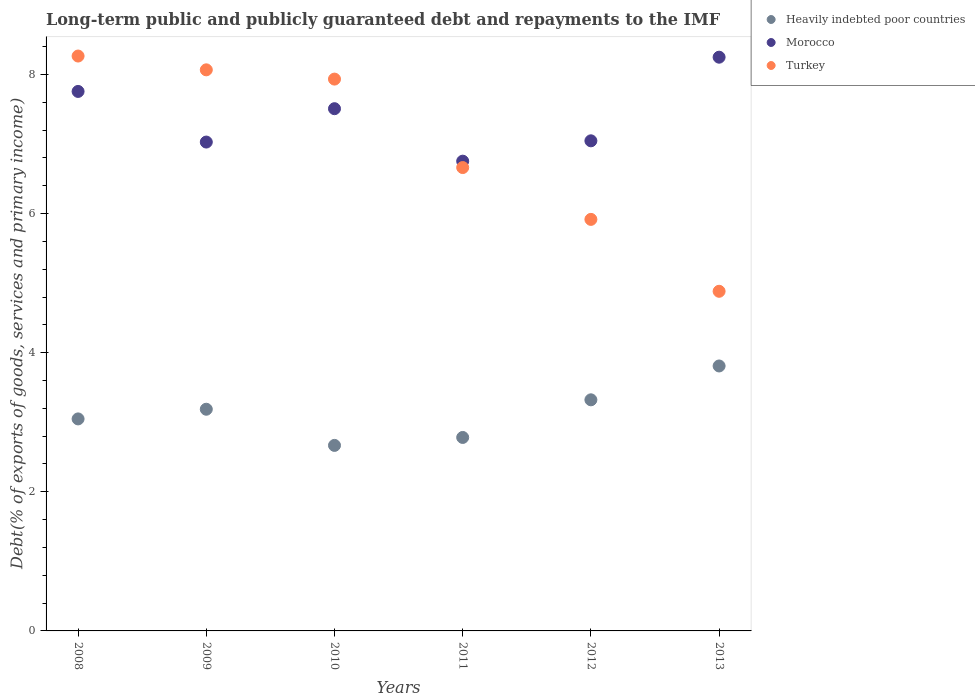What is the debt and repayments in Turkey in 2013?
Provide a short and direct response. 4.88. Across all years, what is the maximum debt and repayments in Morocco?
Your response must be concise. 8.25. Across all years, what is the minimum debt and repayments in Morocco?
Ensure brevity in your answer.  6.75. What is the total debt and repayments in Morocco in the graph?
Provide a short and direct response. 44.34. What is the difference between the debt and repayments in Morocco in 2010 and that in 2011?
Provide a short and direct response. 0.75. What is the difference between the debt and repayments in Heavily indebted poor countries in 2012 and the debt and repayments in Turkey in 2010?
Provide a short and direct response. -4.61. What is the average debt and repayments in Heavily indebted poor countries per year?
Provide a short and direct response. 3.14. In the year 2012, what is the difference between the debt and repayments in Heavily indebted poor countries and debt and repayments in Morocco?
Provide a succinct answer. -3.72. In how many years, is the debt and repayments in Morocco greater than 7.6 %?
Your response must be concise. 2. What is the ratio of the debt and repayments in Turkey in 2010 to that in 2012?
Keep it short and to the point. 1.34. Is the debt and repayments in Heavily indebted poor countries in 2009 less than that in 2012?
Provide a short and direct response. Yes. Is the difference between the debt and repayments in Heavily indebted poor countries in 2010 and 2011 greater than the difference between the debt and repayments in Morocco in 2010 and 2011?
Your answer should be very brief. No. What is the difference between the highest and the second highest debt and repayments in Morocco?
Your answer should be very brief. 0.49. What is the difference between the highest and the lowest debt and repayments in Morocco?
Keep it short and to the point. 1.49. In how many years, is the debt and repayments in Heavily indebted poor countries greater than the average debt and repayments in Heavily indebted poor countries taken over all years?
Your answer should be very brief. 3. Is the sum of the debt and repayments in Heavily indebted poor countries in 2008 and 2010 greater than the maximum debt and repayments in Turkey across all years?
Your response must be concise. No. Is it the case that in every year, the sum of the debt and repayments in Turkey and debt and repayments in Morocco  is greater than the debt and repayments in Heavily indebted poor countries?
Your answer should be very brief. Yes. Does the debt and repayments in Turkey monotonically increase over the years?
Your answer should be very brief. No. What is the difference between two consecutive major ticks on the Y-axis?
Keep it short and to the point. 2. Does the graph contain any zero values?
Give a very brief answer. No. How many legend labels are there?
Offer a terse response. 3. How are the legend labels stacked?
Your answer should be compact. Vertical. What is the title of the graph?
Give a very brief answer. Long-term public and publicly guaranteed debt and repayments to the IMF. What is the label or title of the Y-axis?
Offer a very short reply. Debt(% of exports of goods, services and primary income). What is the Debt(% of exports of goods, services and primary income) of Heavily indebted poor countries in 2008?
Provide a short and direct response. 3.05. What is the Debt(% of exports of goods, services and primary income) of Morocco in 2008?
Provide a short and direct response. 7.76. What is the Debt(% of exports of goods, services and primary income) of Turkey in 2008?
Give a very brief answer. 8.26. What is the Debt(% of exports of goods, services and primary income) in Heavily indebted poor countries in 2009?
Offer a terse response. 3.19. What is the Debt(% of exports of goods, services and primary income) of Morocco in 2009?
Your answer should be very brief. 7.03. What is the Debt(% of exports of goods, services and primary income) in Turkey in 2009?
Keep it short and to the point. 8.07. What is the Debt(% of exports of goods, services and primary income) in Heavily indebted poor countries in 2010?
Offer a very short reply. 2.67. What is the Debt(% of exports of goods, services and primary income) of Morocco in 2010?
Offer a terse response. 7.51. What is the Debt(% of exports of goods, services and primary income) in Turkey in 2010?
Your answer should be compact. 7.93. What is the Debt(% of exports of goods, services and primary income) of Heavily indebted poor countries in 2011?
Make the answer very short. 2.78. What is the Debt(% of exports of goods, services and primary income) of Morocco in 2011?
Offer a very short reply. 6.75. What is the Debt(% of exports of goods, services and primary income) of Turkey in 2011?
Offer a very short reply. 6.66. What is the Debt(% of exports of goods, services and primary income) in Heavily indebted poor countries in 2012?
Give a very brief answer. 3.32. What is the Debt(% of exports of goods, services and primary income) in Morocco in 2012?
Your response must be concise. 7.05. What is the Debt(% of exports of goods, services and primary income) in Turkey in 2012?
Offer a very short reply. 5.92. What is the Debt(% of exports of goods, services and primary income) in Heavily indebted poor countries in 2013?
Make the answer very short. 3.81. What is the Debt(% of exports of goods, services and primary income) in Morocco in 2013?
Your answer should be very brief. 8.25. What is the Debt(% of exports of goods, services and primary income) in Turkey in 2013?
Your answer should be compact. 4.88. Across all years, what is the maximum Debt(% of exports of goods, services and primary income) in Heavily indebted poor countries?
Your response must be concise. 3.81. Across all years, what is the maximum Debt(% of exports of goods, services and primary income) of Morocco?
Provide a succinct answer. 8.25. Across all years, what is the maximum Debt(% of exports of goods, services and primary income) in Turkey?
Make the answer very short. 8.26. Across all years, what is the minimum Debt(% of exports of goods, services and primary income) in Heavily indebted poor countries?
Ensure brevity in your answer.  2.67. Across all years, what is the minimum Debt(% of exports of goods, services and primary income) in Morocco?
Your answer should be very brief. 6.75. Across all years, what is the minimum Debt(% of exports of goods, services and primary income) in Turkey?
Your answer should be very brief. 4.88. What is the total Debt(% of exports of goods, services and primary income) in Heavily indebted poor countries in the graph?
Give a very brief answer. 18.81. What is the total Debt(% of exports of goods, services and primary income) of Morocco in the graph?
Offer a terse response. 44.34. What is the total Debt(% of exports of goods, services and primary income) in Turkey in the graph?
Offer a terse response. 41.72. What is the difference between the Debt(% of exports of goods, services and primary income) of Heavily indebted poor countries in 2008 and that in 2009?
Provide a short and direct response. -0.14. What is the difference between the Debt(% of exports of goods, services and primary income) of Morocco in 2008 and that in 2009?
Ensure brevity in your answer.  0.73. What is the difference between the Debt(% of exports of goods, services and primary income) in Turkey in 2008 and that in 2009?
Your answer should be very brief. 0.2. What is the difference between the Debt(% of exports of goods, services and primary income) of Heavily indebted poor countries in 2008 and that in 2010?
Your answer should be very brief. 0.38. What is the difference between the Debt(% of exports of goods, services and primary income) in Morocco in 2008 and that in 2010?
Make the answer very short. 0.25. What is the difference between the Debt(% of exports of goods, services and primary income) in Turkey in 2008 and that in 2010?
Keep it short and to the point. 0.33. What is the difference between the Debt(% of exports of goods, services and primary income) in Heavily indebted poor countries in 2008 and that in 2011?
Make the answer very short. 0.27. What is the difference between the Debt(% of exports of goods, services and primary income) in Turkey in 2008 and that in 2011?
Your response must be concise. 1.6. What is the difference between the Debt(% of exports of goods, services and primary income) in Heavily indebted poor countries in 2008 and that in 2012?
Keep it short and to the point. -0.27. What is the difference between the Debt(% of exports of goods, services and primary income) of Morocco in 2008 and that in 2012?
Give a very brief answer. 0.71. What is the difference between the Debt(% of exports of goods, services and primary income) of Turkey in 2008 and that in 2012?
Your answer should be compact. 2.35. What is the difference between the Debt(% of exports of goods, services and primary income) in Heavily indebted poor countries in 2008 and that in 2013?
Your answer should be very brief. -0.76. What is the difference between the Debt(% of exports of goods, services and primary income) in Morocco in 2008 and that in 2013?
Ensure brevity in your answer.  -0.49. What is the difference between the Debt(% of exports of goods, services and primary income) of Turkey in 2008 and that in 2013?
Offer a terse response. 3.38. What is the difference between the Debt(% of exports of goods, services and primary income) in Heavily indebted poor countries in 2009 and that in 2010?
Provide a succinct answer. 0.52. What is the difference between the Debt(% of exports of goods, services and primary income) in Morocco in 2009 and that in 2010?
Provide a short and direct response. -0.48. What is the difference between the Debt(% of exports of goods, services and primary income) of Turkey in 2009 and that in 2010?
Your answer should be compact. 0.13. What is the difference between the Debt(% of exports of goods, services and primary income) in Heavily indebted poor countries in 2009 and that in 2011?
Provide a short and direct response. 0.41. What is the difference between the Debt(% of exports of goods, services and primary income) in Morocco in 2009 and that in 2011?
Provide a succinct answer. 0.27. What is the difference between the Debt(% of exports of goods, services and primary income) in Turkey in 2009 and that in 2011?
Offer a terse response. 1.4. What is the difference between the Debt(% of exports of goods, services and primary income) in Heavily indebted poor countries in 2009 and that in 2012?
Provide a succinct answer. -0.14. What is the difference between the Debt(% of exports of goods, services and primary income) of Morocco in 2009 and that in 2012?
Give a very brief answer. -0.02. What is the difference between the Debt(% of exports of goods, services and primary income) in Turkey in 2009 and that in 2012?
Give a very brief answer. 2.15. What is the difference between the Debt(% of exports of goods, services and primary income) of Heavily indebted poor countries in 2009 and that in 2013?
Make the answer very short. -0.62. What is the difference between the Debt(% of exports of goods, services and primary income) in Morocco in 2009 and that in 2013?
Give a very brief answer. -1.22. What is the difference between the Debt(% of exports of goods, services and primary income) of Turkey in 2009 and that in 2013?
Your answer should be compact. 3.18. What is the difference between the Debt(% of exports of goods, services and primary income) in Heavily indebted poor countries in 2010 and that in 2011?
Give a very brief answer. -0.11. What is the difference between the Debt(% of exports of goods, services and primary income) in Morocco in 2010 and that in 2011?
Ensure brevity in your answer.  0.75. What is the difference between the Debt(% of exports of goods, services and primary income) of Turkey in 2010 and that in 2011?
Ensure brevity in your answer.  1.27. What is the difference between the Debt(% of exports of goods, services and primary income) in Heavily indebted poor countries in 2010 and that in 2012?
Offer a terse response. -0.66. What is the difference between the Debt(% of exports of goods, services and primary income) in Morocco in 2010 and that in 2012?
Give a very brief answer. 0.46. What is the difference between the Debt(% of exports of goods, services and primary income) of Turkey in 2010 and that in 2012?
Give a very brief answer. 2.02. What is the difference between the Debt(% of exports of goods, services and primary income) of Heavily indebted poor countries in 2010 and that in 2013?
Offer a terse response. -1.14. What is the difference between the Debt(% of exports of goods, services and primary income) of Morocco in 2010 and that in 2013?
Provide a short and direct response. -0.74. What is the difference between the Debt(% of exports of goods, services and primary income) in Turkey in 2010 and that in 2013?
Provide a short and direct response. 3.05. What is the difference between the Debt(% of exports of goods, services and primary income) in Heavily indebted poor countries in 2011 and that in 2012?
Make the answer very short. -0.54. What is the difference between the Debt(% of exports of goods, services and primary income) in Morocco in 2011 and that in 2012?
Make the answer very short. -0.29. What is the difference between the Debt(% of exports of goods, services and primary income) in Turkey in 2011 and that in 2012?
Make the answer very short. 0.74. What is the difference between the Debt(% of exports of goods, services and primary income) of Heavily indebted poor countries in 2011 and that in 2013?
Ensure brevity in your answer.  -1.03. What is the difference between the Debt(% of exports of goods, services and primary income) in Morocco in 2011 and that in 2013?
Your response must be concise. -1.49. What is the difference between the Debt(% of exports of goods, services and primary income) of Turkey in 2011 and that in 2013?
Make the answer very short. 1.78. What is the difference between the Debt(% of exports of goods, services and primary income) of Heavily indebted poor countries in 2012 and that in 2013?
Give a very brief answer. -0.49. What is the difference between the Debt(% of exports of goods, services and primary income) in Morocco in 2012 and that in 2013?
Your answer should be very brief. -1.2. What is the difference between the Debt(% of exports of goods, services and primary income) of Turkey in 2012 and that in 2013?
Your response must be concise. 1.03. What is the difference between the Debt(% of exports of goods, services and primary income) in Heavily indebted poor countries in 2008 and the Debt(% of exports of goods, services and primary income) in Morocco in 2009?
Keep it short and to the point. -3.98. What is the difference between the Debt(% of exports of goods, services and primary income) in Heavily indebted poor countries in 2008 and the Debt(% of exports of goods, services and primary income) in Turkey in 2009?
Your answer should be very brief. -5.02. What is the difference between the Debt(% of exports of goods, services and primary income) in Morocco in 2008 and the Debt(% of exports of goods, services and primary income) in Turkey in 2009?
Offer a terse response. -0.31. What is the difference between the Debt(% of exports of goods, services and primary income) in Heavily indebted poor countries in 2008 and the Debt(% of exports of goods, services and primary income) in Morocco in 2010?
Your answer should be compact. -4.46. What is the difference between the Debt(% of exports of goods, services and primary income) in Heavily indebted poor countries in 2008 and the Debt(% of exports of goods, services and primary income) in Turkey in 2010?
Your answer should be very brief. -4.89. What is the difference between the Debt(% of exports of goods, services and primary income) of Morocco in 2008 and the Debt(% of exports of goods, services and primary income) of Turkey in 2010?
Provide a succinct answer. -0.18. What is the difference between the Debt(% of exports of goods, services and primary income) of Heavily indebted poor countries in 2008 and the Debt(% of exports of goods, services and primary income) of Morocco in 2011?
Give a very brief answer. -3.71. What is the difference between the Debt(% of exports of goods, services and primary income) in Heavily indebted poor countries in 2008 and the Debt(% of exports of goods, services and primary income) in Turkey in 2011?
Offer a very short reply. -3.61. What is the difference between the Debt(% of exports of goods, services and primary income) in Morocco in 2008 and the Debt(% of exports of goods, services and primary income) in Turkey in 2011?
Ensure brevity in your answer.  1.09. What is the difference between the Debt(% of exports of goods, services and primary income) of Heavily indebted poor countries in 2008 and the Debt(% of exports of goods, services and primary income) of Morocco in 2012?
Offer a terse response. -4. What is the difference between the Debt(% of exports of goods, services and primary income) of Heavily indebted poor countries in 2008 and the Debt(% of exports of goods, services and primary income) of Turkey in 2012?
Offer a terse response. -2.87. What is the difference between the Debt(% of exports of goods, services and primary income) in Morocco in 2008 and the Debt(% of exports of goods, services and primary income) in Turkey in 2012?
Offer a terse response. 1.84. What is the difference between the Debt(% of exports of goods, services and primary income) of Heavily indebted poor countries in 2008 and the Debt(% of exports of goods, services and primary income) of Turkey in 2013?
Offer a very short reply. -1.83. What is the difference between the Debt(% of exports of goods, services and primary income) of Morocco in 2008 and the Debt(% of exports of goods, services and primary income) of Turkey in 2013?
Provide a short and direct response. 2.87. What is the difference between the Debt(% of exports of goods, services and primary income) of Heavily indebted poor countries in 2009 and the Debt(% of exports of goods, services and primary income) of Morocco in 2010?
Keep it short and to the point. -4.32. What is the difference between the Debt(% of exports of goods, services and primary income) in Heavily indebted poor countries in 2009 and the Debt(% of exports of goods, services and primary income) in Turkey in 2010?
Your response must be concise. -4.75. What is the difference between the Debt(% of exports of goods, services and primary income) in Morocco in 2009 and the Debt(% of exports of goods, services and primary income) in Turkey in 2010?
Provide a short and direct response. -0.91. What is the difference between the Debt(% of exports of goods, services and primary income) in Heavily indebted poor countries in 2009 and the Debt(% of exports of goods, services and primary income) in Morocco in 2011?
Offer a very short reply. -3.57. What is the difference between the Debt(% of exports of goods, services and primary income) of Heavily indebted poor countries in 2009 and the Debt(% of exports of goods, services and primary income) of Turkey in 2011?
Provide a succinct answer. -3.47. What is the difference between the Debt(% of exports of goods, services and primary income) of Morocco in 2009 and the Debt(% of exports of goods, services and primary income) of Turkey in 2011?
Offer a very short reply. 0.37. What is the difference between the Debt(% of exports of goods, services and primary income) in Heavily indebted poor countries in 2009 and the Debt(% of exports of goods, services and primary income) in Morocco in 2012?
Provide a succinct answer. -3.86. What is the difference between the Debt(% of exports of goods, services and primary income) of Heavily indebted poor countries in 2009 and the Debt(% of exports of goods, services and primary income) of Turkey in 2012?
Your answer should be compact. -2.73. What is the difference between the Debt(% of exports of goods, services and primary income) in Morocco in 2009 and the Debt(% of exports of goods, services and primary income) in Turkey in 2012?
Provide a short and direct response. 1.11. What is the difference between the Debt(% of exports of goods, services and primary income) in Heavily indebted poor countries in 2009 and the Debt(% of exports of goods, services and primary income) in Morocco in 2013?
Keep it short and to the point. -5.06. What is the difference between the Debt(% of exports of goods, services and primary income) of Heavily indebted poor countries in 2009 and the Debt(% of exports of goods, services and primary income) of Turkey in 2013?
Provide a succinct answer. -1.7. What is the difference between the Debt(% of exports of goods, services and primary income) of Morocco in 2009 and the Debt(% of exports of goods, services and primary income) of Turkey in 2013?
Ensure brevity in your answer.  2.15. What is the difference between the Debt(% of exports of goods, services and primary income) of Heavily indebted poor countries in 2010 and the Debt(% of exports of goods, services and primary income) of Morocco in 2011?
Give a very brief answer. -4.09. What is the difference between the Debt(% of exports of goods, services and primary income) in Heavily indebted poor countries in 2010 and the Debt(% of exports of goods, services and primary income) in Turkey in 2011?
Give a very brief answer. -3.99. What is the difference between the Debt(% of exports of goods, services and primary income) of Morocco in 2010 and the Debt(% of exports of goods, services and primary income) of Turkey in 2011?
Give a very brief answer. 0.85. What is the difference between the Debt(% of exports of goods, services and primary income) of Heavily indebted poor countries in 2010 and the Debt(% of exports of goods, services and primary income) of Morocco in 2012?
Provide a short and direct response. -4.38. What is the difference between the Debt(% of exports of goods, services and primary income) in Heavily indebted poor countries in 2010 and the Debt(% of exports of goods, services and primary income) in Turkey in 2012?
Give a very brief answer. -3.25. What is the difference between the Debt(% of exports of goods, services and primary income) in Morocco in 2010 and the Debt(% of exports of goods, services and primary income) in Turkey in 2012?
Offer a terse response. 1.59. What is the difference between the Debt(% of exports of goods, services and primary income) in Heavily indebted poor countries in 2010 and the Debt(% of exports of goods, services and primary income) in Morocco in 2013?
Keep it short and to the point. -5.58. What is the difference between the Debt(% of exports of goods, services and primary income) of Heavily indebted poor countries in 2010 and the Debt(% of exports of goods, services and primary income) of Turkey in 2013?
Provide a short and direct response. -2.22. What is the difference between the Debt(% of exports of goods, services and primary income) in Morocco in 2010 and the Debt(% of exports of goods, services and primary income) in Turkey in 2013?
Your response must be concise. 2.62. What is the difference between the Debt(% of exports of goods, services and primary income) in Heavily indebted poor countries in 2011 and the Debt(% of exports of goods, services and primary income) in Morocco in 2012?
Make the answer very short. -4.26. What is the difference between the Debt(% of exports of goods, services and primary income) in Heavily indebted poor countries in 2011 and the Debt(% of exports of goods, services and primary income) in Turkey in 2012?
Your answer should be compact. -3.13. What is the difference between the Debt(% of exports of goods, services and primary income) in Morocco in 2011 and the Debt(% of exports of goods, services and primary income) in Turkey in 2012?
Offer a terse response. 0.84. What is the difference between the Debt(% of exports of goods, services and primary income) in Heavily indebted poor countries in 2011 and the Debt(% of exports of goods, services and primary income) in Morocco in 2013?
Your response must be concise. -5.47. What is the difference between the Debt(% of exports of goods, services and primary income) of Heavily indebted poor countries in 2011 and the Debt(% of exports of goods, services and primary income) of Turkey in 2013?
Your answer should be very brief. -2.1. What is the difference between the Debt(% of exports of goods, services and primary income) of Morocco in 2011 and the Debt(% of exports of goods, services and primary income) of Turkey in 2013?
Your answer should be very brief. 1.87. What is the difference between the Debt(% of exports of goods, services and primary income) of Heavily indebted poor countries in 2012 and the Debt(% of exports of goods, services and primary income) of Morocco in 2013?
Your response must be concise. -4.93. What is the difference between the Debt(% of exports of goods, services and primary income) in Heavily indebted poor countries in 2012 and the Debt(% of exports of goods, services and primary income) in Turkey in 2013?
Your response must be concise. -1.56. What is the difference between the Debt(% of exports of goods, services and primary income) in Morocco in 2012 and the Debt(% of exports of goods, services and primary income) in Turkey in 2013?
Your answer should be compact. 2.16. What is the average Debt(% of exports of goods, services and primary income) of Heavily indebted poor countries per year?
Your response must be concise. 3.14. What is the average Debt(% of exports of goods, services and primary income) of Morocco per year?
Your response must be concise. 7.39. What is the average Debt(% of exports of goods, services and primary income) in Turkey per year?
Provide a short and direct response. 6.95. In the year 2008, what is the difference between the Debt(% of exports of goods, services and primary income) in Heavily indebted poor countries and Debt(% of exports of goods, services and primary income) in Morocco?
Your answer should be very brief. -4.71. In the year 2008, what is the difference between the Debt(% of exports of goods, services and primary income) in Heavily indebted poor countries and Debt(% of exports of goods, services and primary income) in Turkey?
Offer a very short reply. -5.22. In the year 2008, what is the difference between the Debt(% of exports of goods, services and primary income) of Morocco and Debt(% of exports of goods, services and primary income) of Turkey?
Give a very brief answer. -0.51. In the year 2009, what is the difference between the Debt(% of exports of goods, services and primary income) in Heavily indebted poor countries and Debt(% of exports of goods, services and primary income) in Morocco?
Ensure brevity in your answer.  -3.84. In the year 2009, what is the difference between the Debt(% of exports of goods, services and primary income) in Heavily indebted poor countries and Debt(% of exports of goods, services and primary income) in Turkey?
Provide a succinct answer. -4.88. In the year 2009, what is the difference between the Debt(% of exports of goods, services and primary income) of Morocco and Debt(% of exports of goods, services and primary income) of Turkey?
Your answer should be very brief. -1.04. In the year 2010, what is the difference between the Debt(% of exports of goods, services and primary income) of Heavily indebted poor countries and Debt(% of exports of goods, services and primary income) of Morocco?
Provide a short and direct response. -4.84. In the year 2010, what is the difference between the Debt(% of exports of goods, services and primary income) in Heavily indebted poor countries and Debt(% of exports of goods, services and primary income) in Turkey?
Offer a terse response. -5.27. In the year 2010, what is the difference between the Debt(% of exports of goods, services and primary income) in Morocco and Debt(% of exports of goods, services and primary income) in Turkey?
Provide a short and direct response. -0.43. In the year 2011, what is the difference between the Debt(% of exports of goods, services and primary income) in Heavily indebted poor countries and Debt(% of exports of goods, services and primary income) in Morocco?
Your answer should be very brief. -3.97. In the year 2011, what is the difference between the Debt(% of exports of goods, services and primary income) of Heavily indebted poor countries and Debt(% of exports of goods, services and primary income) of Turkey?
Offer a very short reply. -3.88. In the year 2011, what is the difference between the Debt(% of exports of goods, services and primary income) of Morocco and Debt(% of exports of goods, services and primary income) of Turkey?
Offer a very short reply. 0.09. In the year 2012, what is the difference between the Debt(% of exports of goods, services and primary income) of Heavily indebted poor countries and Debt(% of exports of goods, services and primary income) of Morocco?
Keep it short and to the point. -3.72. In the year 2012, what is the difference between the Debt(% of exports of goods, services and primary income) of Heavily indebted poor countries and Debt(% of exports of goods, services and primary income) of Turkey?
Your response must be concise. -2.59. In the year 2012, what is the difference between the Debt(% of exports of goods, services and primary income) of Morocco and Debt(% of exports of goods, services and primary income) of Turkey?
Ensure brevity in your answer.  1.13. In the year 2013, what is the difference between the Debt(% of exports of goods, services and primary income) of Heavily indebted poor countries and Debt(% of exports of goods, services and primary income) of Morocco?
Offer a terse response. -4.44. In the year 2013, what is the difference between the Debt(% of exports of goods, services and primary income) in Heavily indebted poor countries and Debt(% of exports of goods, services and primary income) in Turkey?
Offer a very short reply. -1.07. In the year 2013, what is the difference between the Debt(% of exports of goods, services and primary income) of Morocco and Debt(% of exports of goods, services and primary income) of Turkey?
Ensure brevity in your answer.  3.37. What is the ratio of the Debt(% of exports of goods, services and primary income) in Heavily indebted poor countries in 2008 to that in 2009?
Offer a terse response. 0.96. What is the ratio of the Debt(% of exports of goods, services and primary income) of Morocco in 2008 to that in 2009?
Ensure brevity in your answer.  1.1. What is the ratio of the Debt(% of exports of goods, services and primary income) of Turkey in 2008 to that in 2009?
Ensure brevity in your answer.  1.02. What is the ratio of the Debt(% of exports of goods, services and primary income) in Heavily indebted poor countries in 2008 to that in 2010?
Offer a terse response. 1.14. What is the ratio of the Debt(% of exports of goods, services and primary income) of Morocco in 2008 to that in 2010?
Your response must be concise. 1.03. What is the ratio of the Debt(% of exports of goods, services and primary income) in Turkey in 2008 to that in 2010?
Offer a very short reply. 1.04. What is the ratio of the Debt(% of exports of goods, services and primary income) of Heavily indebted poor countries in 2008 to that in 2011?
Ensure brevity in your answer.  1.1. What is the ratio of the Debt(% of exports of goods, services and primary income) of Morocco in 2008 to that in 2011?
Ensure brevity in your answer.  1.15. What is the ratio of the Debt(% of exports of goods, services and primary income) of Turkey in 2008 to that in 2011?
Offer a terse response. 1.24. What is the ratio of the Debt(% of exports of goods, services and primary income) of Heavily indebted poor countries in 2008 to that in 2012?
Provide a succinct answer. 0.92. What is the ratio of the Debt(% of exports of goods, services and primary income) of Morocco in 2008 to that in 2012?
Make the answer very short. 1.1. What is the ratio of the Debt(% of exports of goods, services and primary income) of Turkey in 2008 to that in 2012?
Your response must be concise. 1.4. What is the ratio of the Debt(% of exports of goods, services and primary income) of Heavily indebted poor countries in 2008 to that in 2013?
Keep it short and to the point. 0.8. What is the ratio of the Debt(% of exports of goods, services and primary income) in Morocco in 2008 to that in 2013?
Offer a terse response. 0.94. What is the ratio of the Debt(% of exports of goods, services and primary income) of Turkey in 2008 to that in 2013?
Ensure brevity in your answer.  1.69. What is the ratio of the Debt(% of exports of goods, services and primary income) of Heavily indebted poor countries in 2009 to that in 2010?
Ensure brevity in your answer.  1.19. What is the ratio of the Debt(% of exports of goods, services and primary income) in Morocco in 2009 to that in 2010?
Your response must be concise. 0.94. What is the ratio of the Debt(% of exports of goods, services and primary income) in Turkey in 2009 to that in 2010?
Provide a short and direct response. 1.02. What is the ratio of the Debt(% of exports of goods, services and primary income) of Heavily indebted poor countries in 2009 to that in 2011?
Your response must be concise. 1.15. What is the ratio of the Debt(% of exports of goods, services and primary income) in Morocco in 2009 to that in 2011?
Offer a very short reply. 1.04. What is the ratio of the Debt(% of exports of goods, services and primary income) of Turkey in 2009 to that in 2011?
Provide a short and direct response. 1.21. What is the ratio of the Debt(% of exports of goods, services and primary income) of Heavily indebted poor countries in 2009 to that in 2012?
Provide a short and direct response. 0.96. What is the ratio of the Debt(% of exports of goods, services and primary income) of Turkey in 2009 to that in 2012?
Provide a short and direct response. 1.36. What is the ratio of the Debt(% of exports of goods, services and primary income) of Heavily indebted poor countries in 2009 to that in 2013?
Give a very brief answer. 0.84. What is the ratio of the Debt(% of exports of goods, services and primary income) of Morocco in 2009 to that in 2013?
Your response must be concise. 0.85. What is the ratio of the Debt(% of exports of goods, services and primary income) in Turkey in 2009 to that in 2013?
Give a very brief answer. 1.65. What is the ratio of the Debt(% of exports of goods, services and primary income) in Heavily indebted poor countries in 2010 to that in 2011?
Give a very brief answer. 0.96. What is the ratio of the Debt(% of exports of goods, services and primary income) in Morocco in 2010 to that in 2011?
Offer a very short reply. 1.11. What is the ratio of the Debt(% of exports of goods, services and primary income) in Turkey in 2010 to that in 2011?
Provide a short and direct response. 1.19. What is the ratio of the Debt(% of exports of goods, services and primary income) of Heavily indebted poor countries in 2010 to that in 2012?
Offer a terse response. 0.8. What is the ratio of the Debt(% of exports of goods, services and primary income) of Morocco in 2010 to that in 2012?
Give a very brief answer. 1.07. What is the ratio of the Debt(% of exports of goods, services and primary income) in Turkey in 2010 to that in 2012?
Provide a succinct answer. 1.34. What is the ratio of the Debt(% of exports of goods, services and primary income) of Heavily indebted poor countries in 2010 to that in 2013?
Give a very brief answer. 0.7. What is the ratio of the Debt(% of exports of goods, services and primary income) of Morocco in 2010 to that in 2013?
Keep it short and to the point. 0.91. What is the ratio of the Debt(% of exports of goods, services and primary income) in Turkey in 2010 to that in 2013?
Ensure brevity in your answer.  1.62. What is the ratio of the Debt(% of exports of goods, services and primary income) in Heavily indebted poor countries in 2011 to that in 2012?
Keep it short and to the point. 0.84. What is the ratio of the Debt(% of exports of goods, services and primary income) of Morocco in 2011 to that in 2012?
Your response must be concise. 0.96. What is the ratio of the Debt(% of exports of goods, services and primary income) in Turkey in 2011 to that in 2012?
Offer a very short reply. 1.13. What is the ratio of the Debt(% of exports of goods, services and primary income) in Heavily indebted poor countries in 2011 to that in 2013?
Give a very brief answer. 0.73. What is the ratio of the Debt(% of exports of goods, services and primary income) in Morocco in 2011 to that in 2013?
Your response must be concise. 0.82. What is the ratio of the Debt(% of exports of goods, services and primary income) of Turkey in 2011 to that in 2013?
Offer a terse response. 1.36. What is the ratio of the Debt(% of exports of goods, services and primary income) in Heavily indebted poor countries in 2012 to that in 2013?
Provide a short and direct response. 0.87. What is the ratio of the Debt(% of exports of goods, services and primary income) in Morocco in 2012 to that in 2013?
Offer a terse response. 0.85. What is the ratio of the Debt(% of exports of goods, services and primary income) in Turkey in 2012 to that in 2013?
Ensure brevity in your answer.  1.21. What is the difference between the highest and the second highest Debt(% of exports of goods, services and primary income) in Heavily indebted poor countries?
Your response must be concise. 0.49. What is the difference between the highest and the second highest Debt(% of exports of goods, services and primary income) of Morocco?
Your answer should be very brief. 0.49. What is the difference between the highest and the second highest Debt(% of exports of goods, services and primary income) of Turkey?
Your response must be concise. 0.2. What is the difference between the highest and the lowest Debt(% of exports of goods, services and primary income) of Heavily indebted poor countries?
Provide a short and direct response. 1.14. What is the difference between the highest and the lowest Debt(% of exports of goods, services and primary income) of Morocco?
Offer a terse response. 1.49. What is the difference between the highest and the lowest Debt(% of exports of goods, services and primary income) in Turkey?
Your response must be concise. 3.38. 